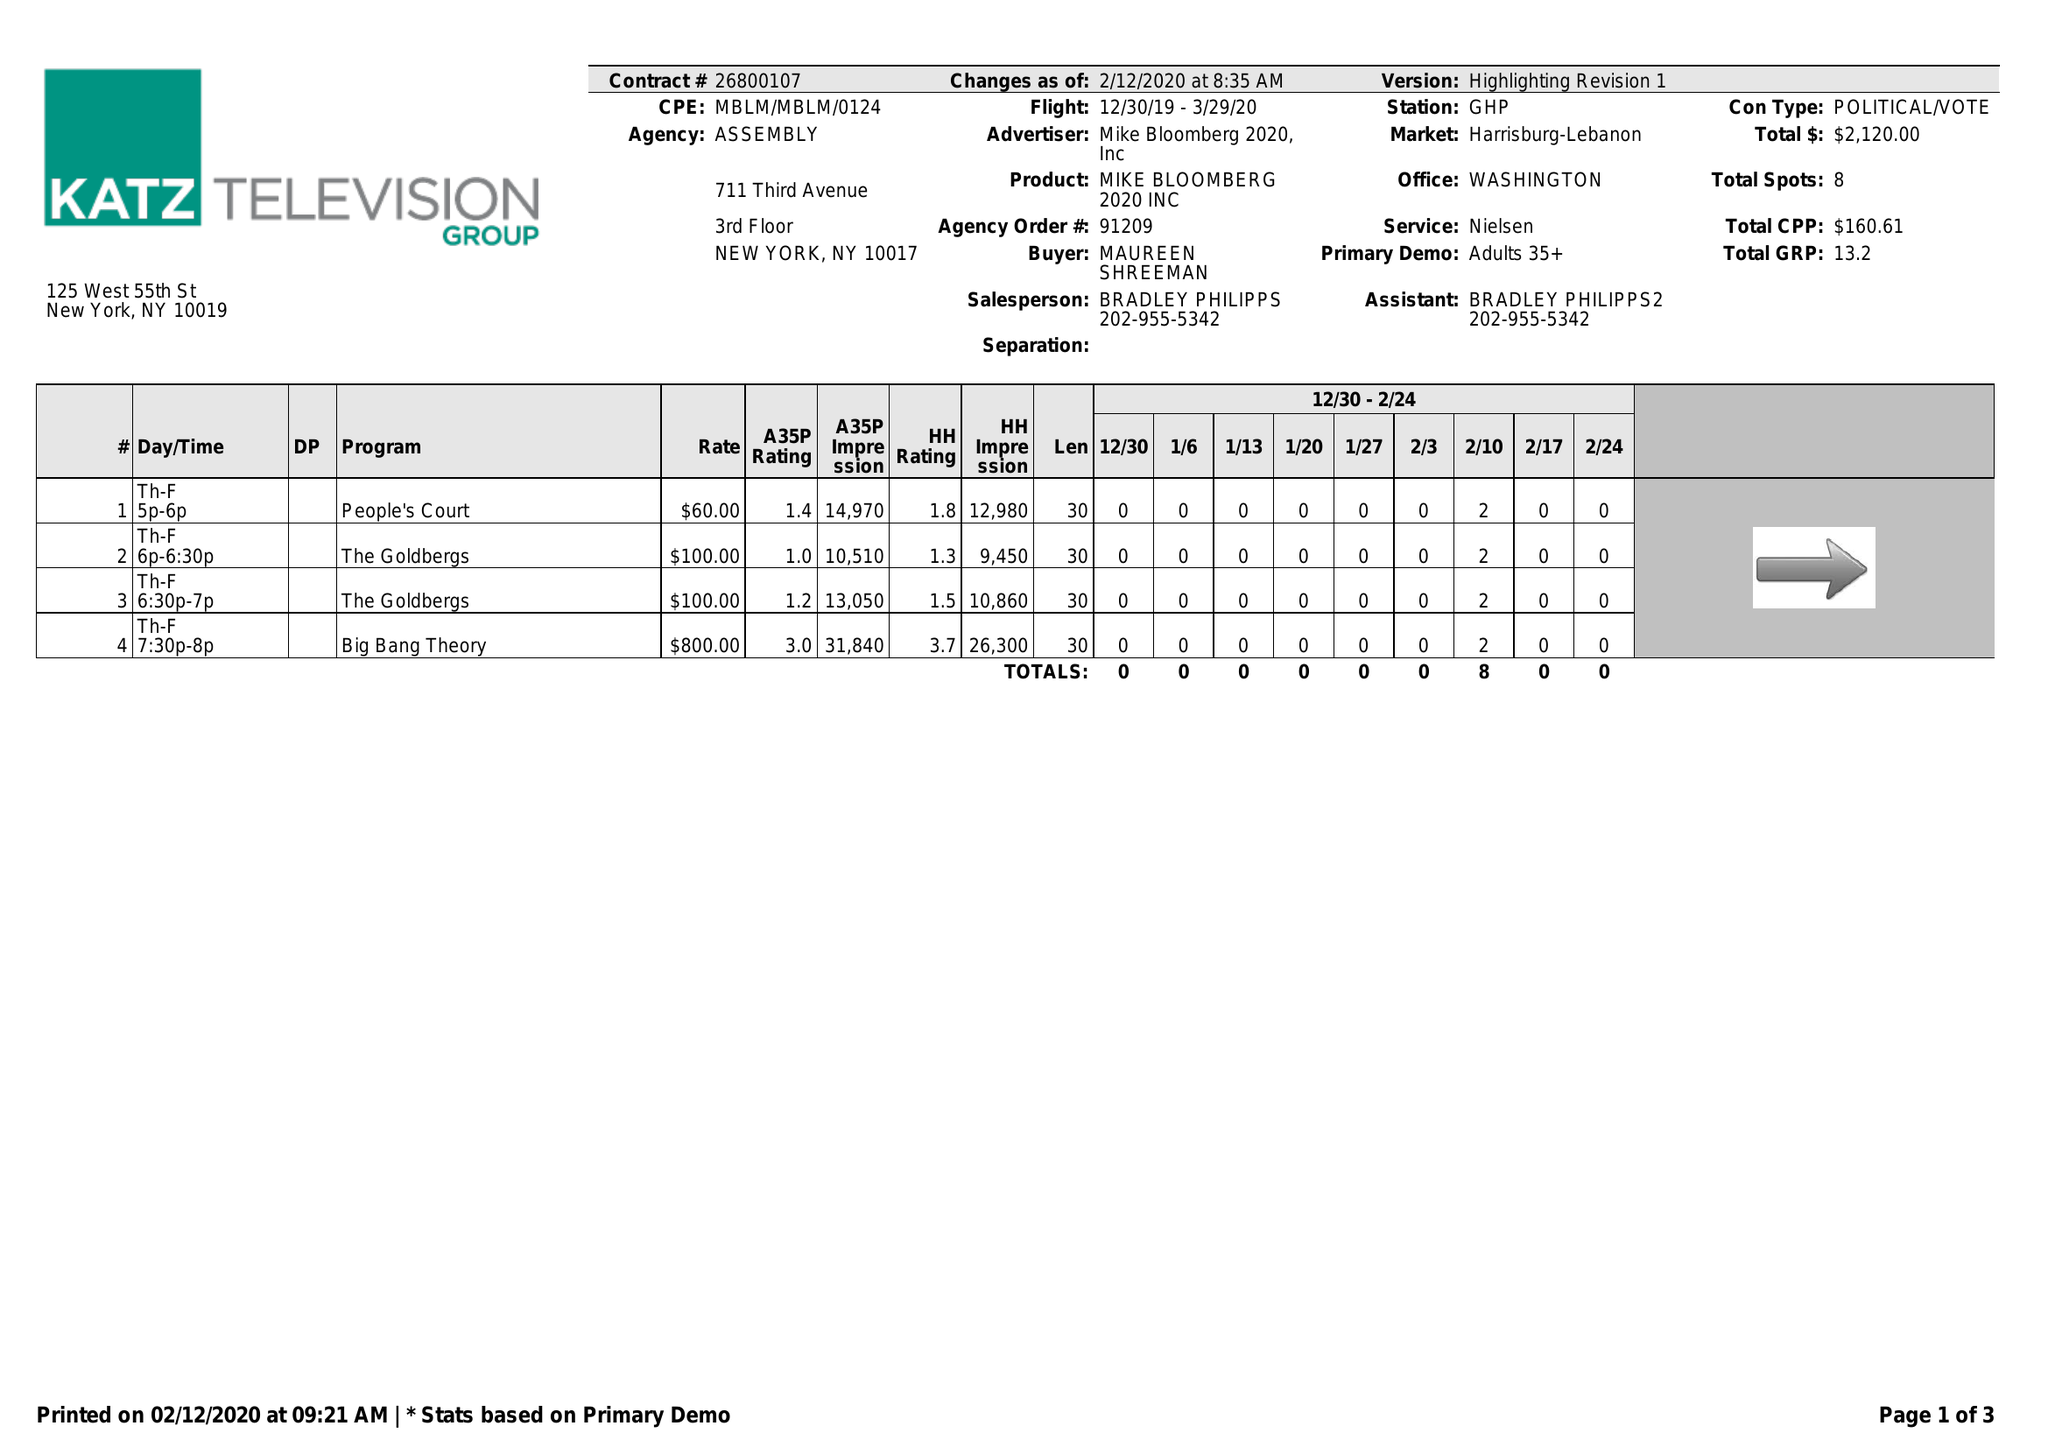What is the value for the flight_from?
Answer the question using a single word or phrase. 12/30/19 